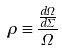Convert formula to latex. <formula><loc_0><loc_0><loc_500><loc_500>\rho \equiv \frac { \frac { d \Omega } { d \Sigma } } { \Omega }</formula> 